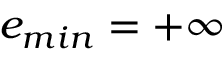<formula> <loc_0><loc_0><loc_500><loc_500>e _ { \min } = + \infty</formula> 